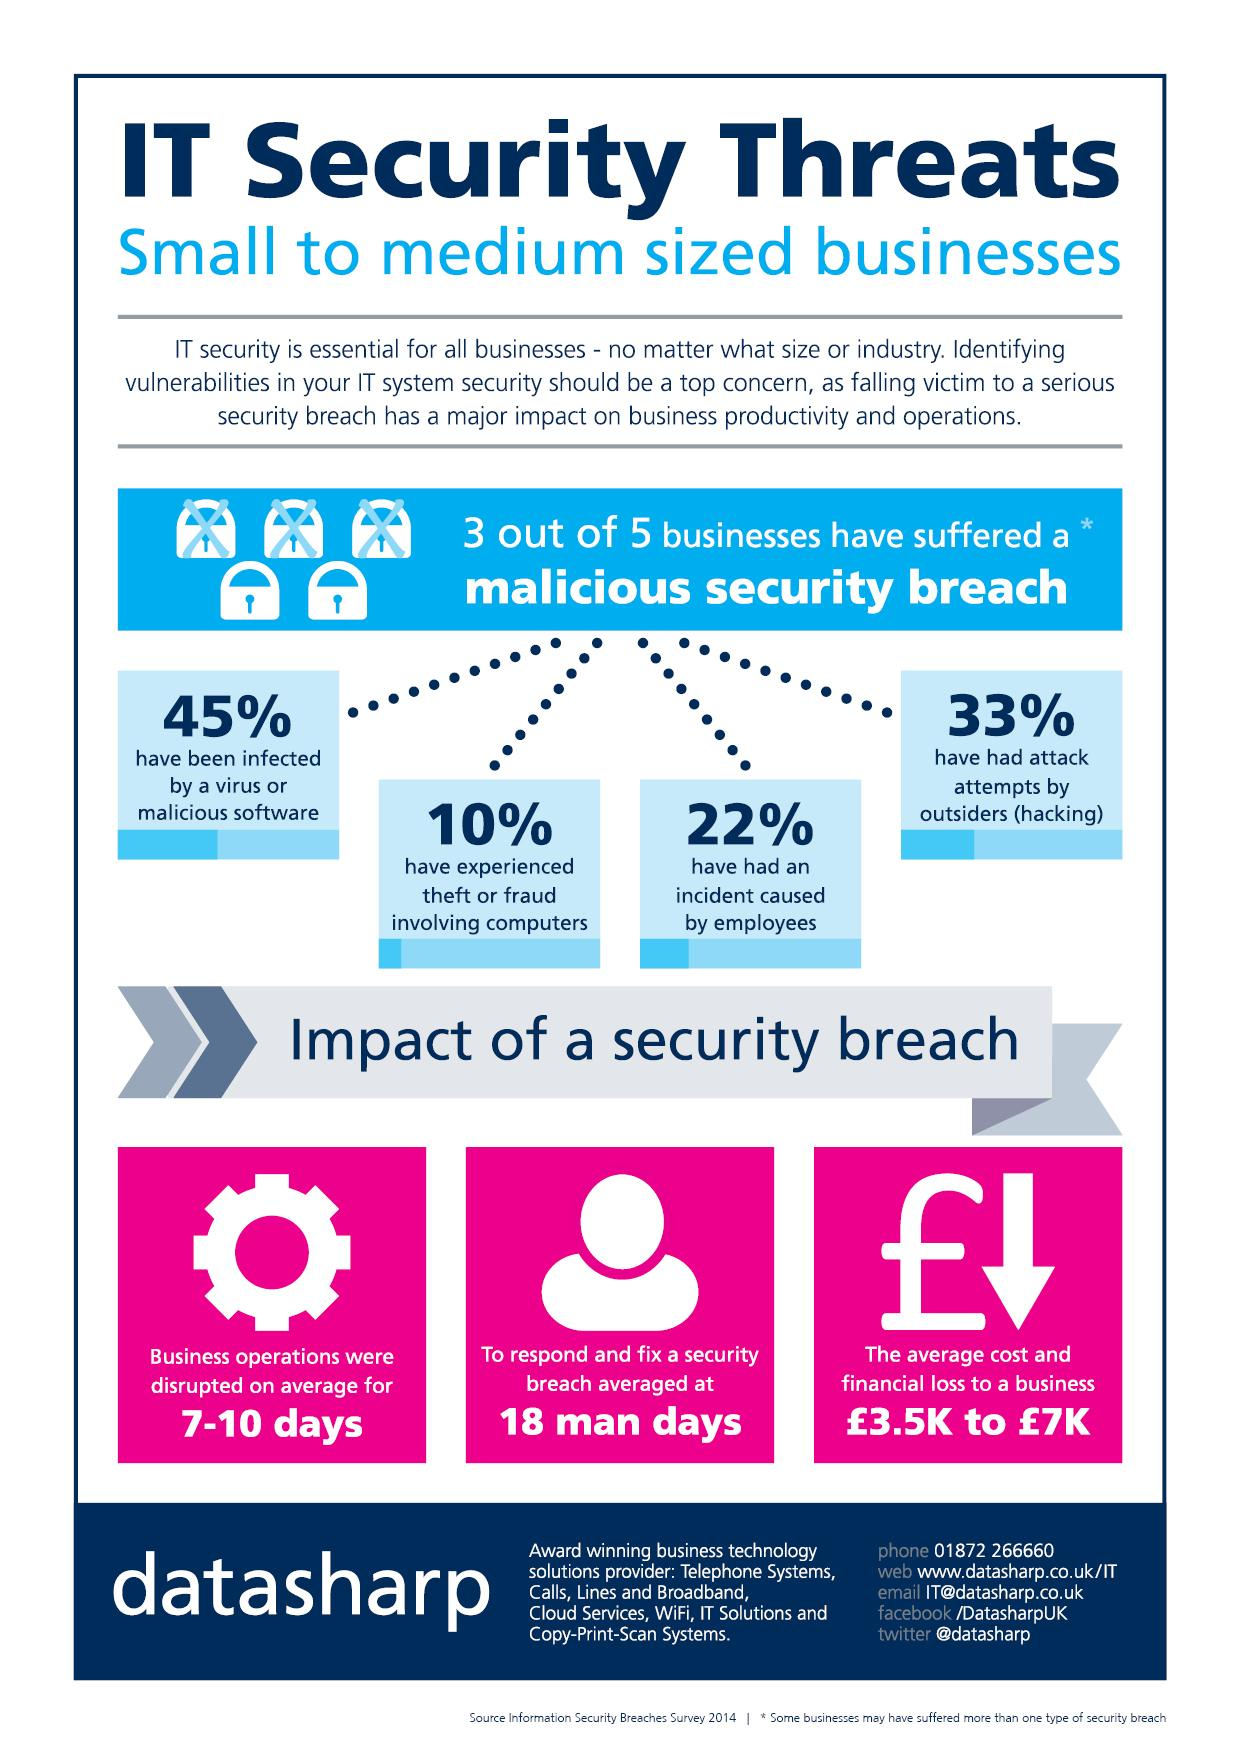List a handful of essential elements in this visual. According to the latest statistics, businesses are most likely to experience a malicious security breach caused by either viruses or malicious software. Approximately 60% of businesses have experienced a malicious security breach. 